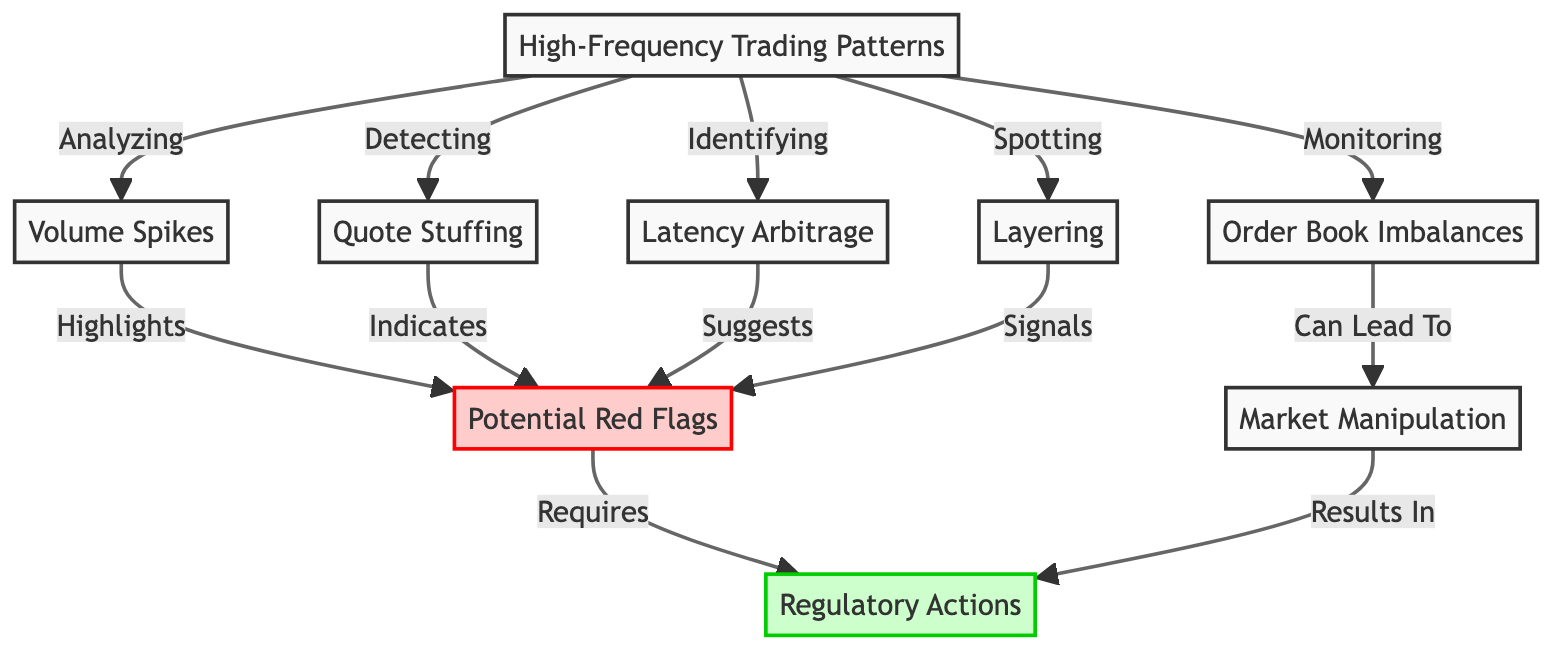What are the nodes directly related to Market Manipulation? The nodes that are directly related to Market Manipulation are Order Book Imbalances, Potential Red Flags, and Regulatory Actions. Market Manipulation is pointed to from Order Book Imbalances according to the arrows.
Answer: Order Book Imbalances, Potential Red Flags, Regulatory Actions How many red flags are indicated in the diagram? The diagram highlights one entity labeled as Potential Red Flags, which collects indicators from several nodes like Volume Spikes, Quote Stuffing, Latency Arbitrage, and Layering. Therefore, there is one primary red flag node.
Answer: One What node indicates the identification of Latency Arbitrage? Latency Arbitrage is related to the node labeled as High-Frequency Trading Patterns, indicating its role as an identifiable aspect within the broader category of trading patterns.
Answer: High-Frequency Trading Patterns What is the connection from Volume Spikes to Potential Red Flags? The diagram illustrates a direct connection where Volume Spikes leads to highlighting Potential Red Flags, indicating that spikes in trading volume can signify potential issues worthy of further investigation.
Answer: Highlights Which node requires Regulatory Actions? The node labeled as Potential Red Flags requires Regulatory Actions, indicating that the identification of red flags in trading patterns necessitates intervention or oversight by regulatory bodies.
Answer: Regulatory Actions What does the node 'Quote Stuffing' indicate as a potential issue? Quote Stuffing points towards Potential Red Flags, suggesting that this trading technique is viewed as an anomaly that could necessitate further scrutiny or investigation.
Answer: Indicates How many distinct trading pattern issues are monitored in the diagram? The diagram entails four distinct trading pattern issues that could potentially be flagged, namely: Volume Spikes, Quote Stuffing, Latency Arbitrage, and Layering.
Answer: Four What is the primary focus of High-Frequency Trading Patterns? High-Frequency Trading Patterns focuses on analyzing various anomalous trading behaviors, with the goal of identifying patterns that could signal market manipulation or other issues.
Answer: Analyzing 